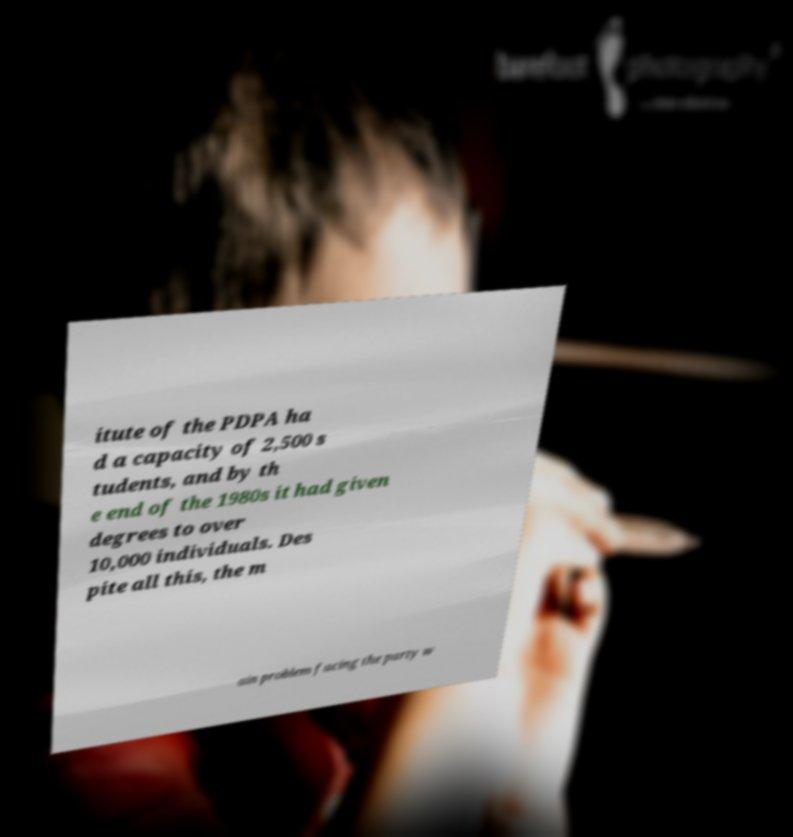There's text embedded in this image that I need extracted. Can you transcribe it verbatim? itute of the PDPA ha d a capacity of 2,500 s tudents, and by th e end of the 1980s it had given degrees to over 10,000 individuals. Des pite all this, the m ain problem facing the party w 